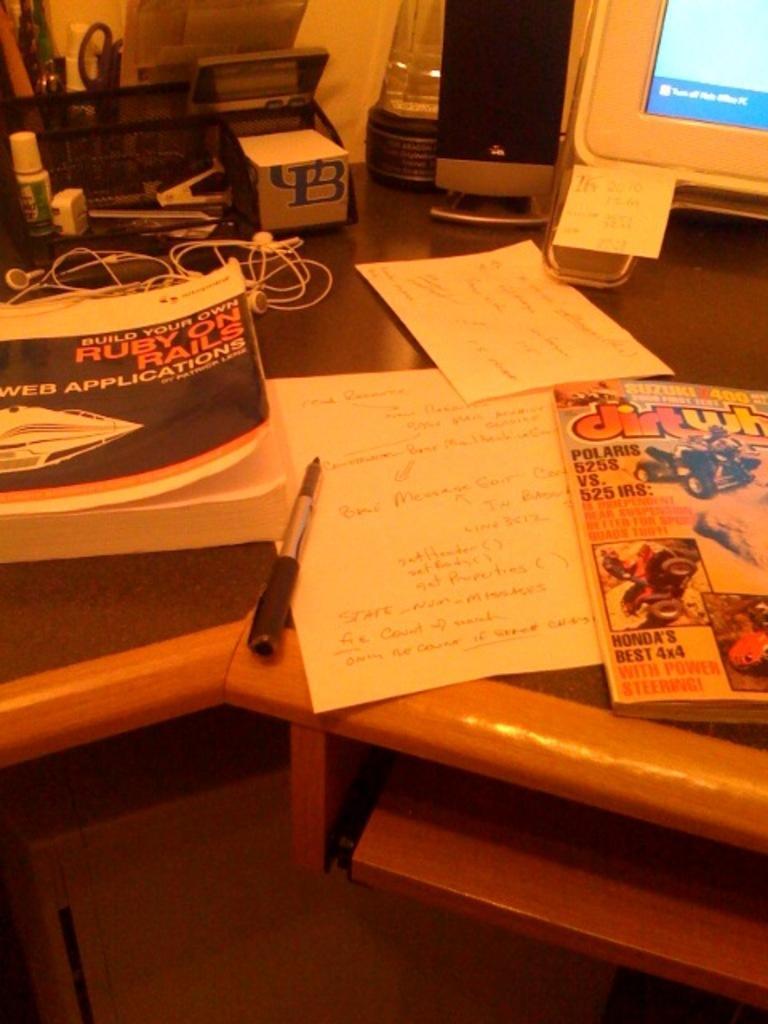How would you summarize this image in a sentence or two? In this image I can see a table. Under the table there is a box. On this table there are some papers, books, pen, wire, bottle, speaker, monitor and some other objects are placed. 